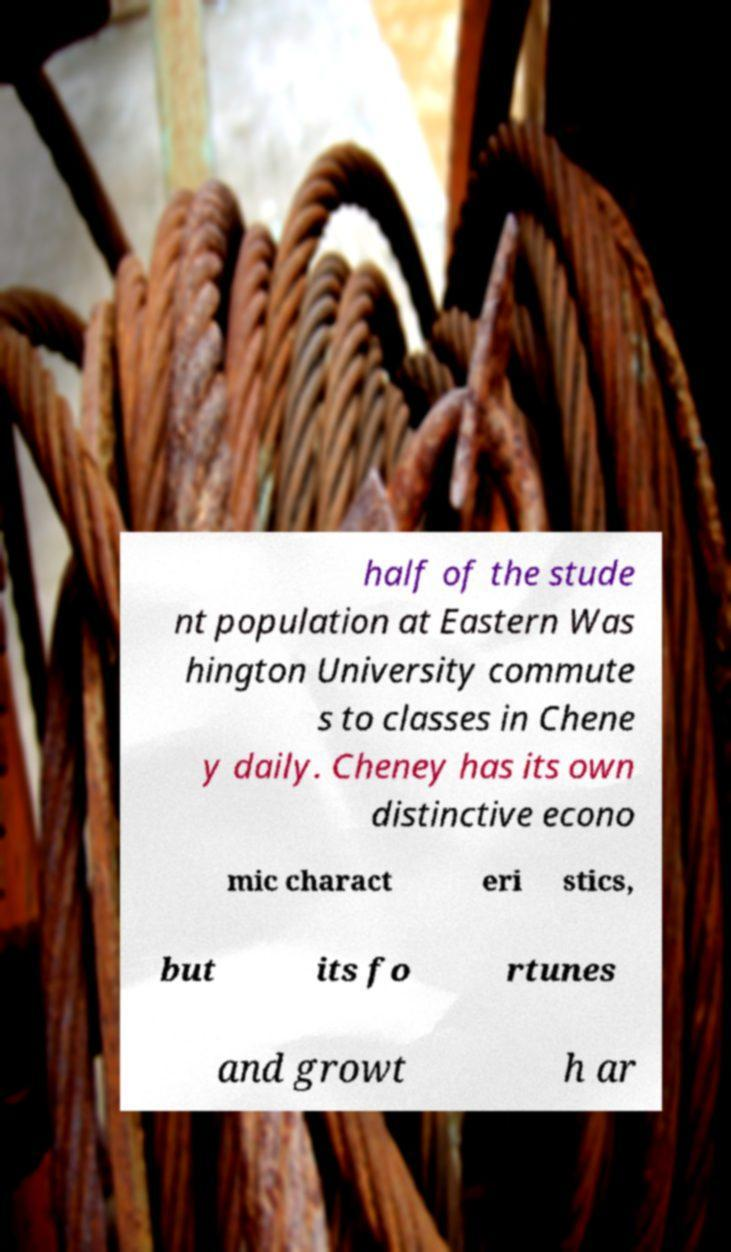For documentation purposes, I need the text within this image transcribed. Could you provide that? half of the stude nt population at Eastern Was hington University commute s to classes in Chene y daily. Cheney has its own distinctive econo mic charact eri stics, but its fo rtunes and growt h ar 